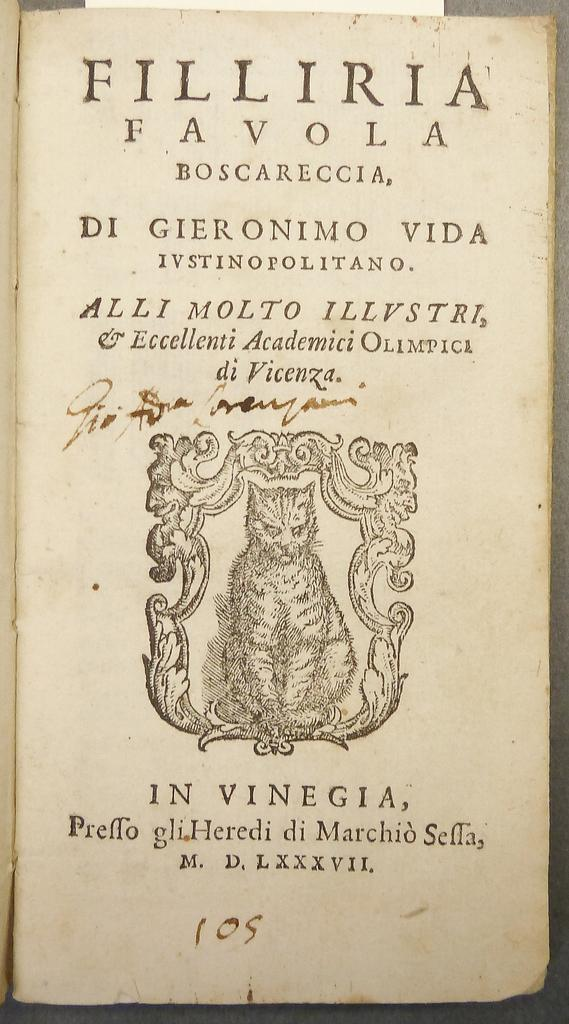<image>
Summarize the visual content of the image. An old book with the number 105 at the bottom. 